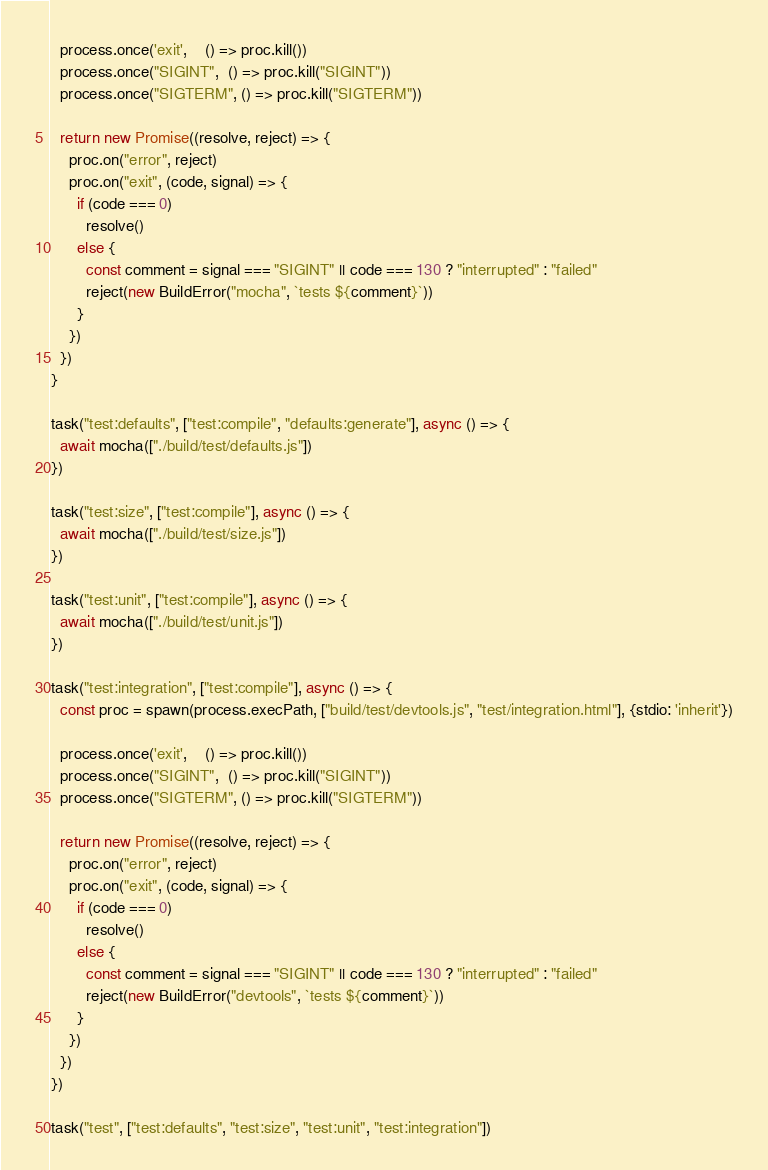Convert code to text. <code><loc_0><loc_0><loc_500><loc_500><_TypeScript_>
  process.once('exit',    () => proc.kill())
  process.once("SIGINT",  () => proc.kill("SIGINT"))
  process.once("SIGTERM", () => proc.kill("SIGTERM"))

  return new Promise((resolve, reject) => {
    proc.on("error", reject)
    proc.on("exit", (code, signal) => {
      if (code === 0)
        resolve()
      else {
        const comment = signal === "SIGINT" || code === 130 ? "interrupted" : "failed"
        reject(new BuildError("mocha", `tests ${comment}`))
      }
    })
  })
}

task("test:defaults", ["test:compile", "defaults:generate"], async () => {
  await mocha(["./build/test/defaults.js"])
})

task("test:size", ["test:compile"], async () => {
  await mocha(["./build/test/size.js"])
})

task("test:unit", ["test:compile"], async () => {
  await mocha(["./build/test/unit.js"])
})

task("test:integration", ["test:compile"], async () => {
  const proc = spawn(process.execPath, ["build/test/devtools.js", "test/integration.html"], {stdio: 'inherit'})

  process.once('exit',    () => proc.kill())
  process.once("SIGINT",  () => proc.kill("SIGINT"))
  process.once("SIGTERM", () => proc.kill("SIGTERM"))

  return new Promise((resolve, reject) => {
    proc.on("error", reject)
    proc.on("exit", (code, signal) => {
      if (code === 0)
        resolve()
      else {
        const comment = signal === "SIGINT" || code === 130 ? "interrupted" : "failed"
        reject(new BuildError("devtools", `tests ${comment}`))
      }
    })
  })
})

task("test", ["test:defaults", "test:size", "test:unit", "test:integration"])
</code> 